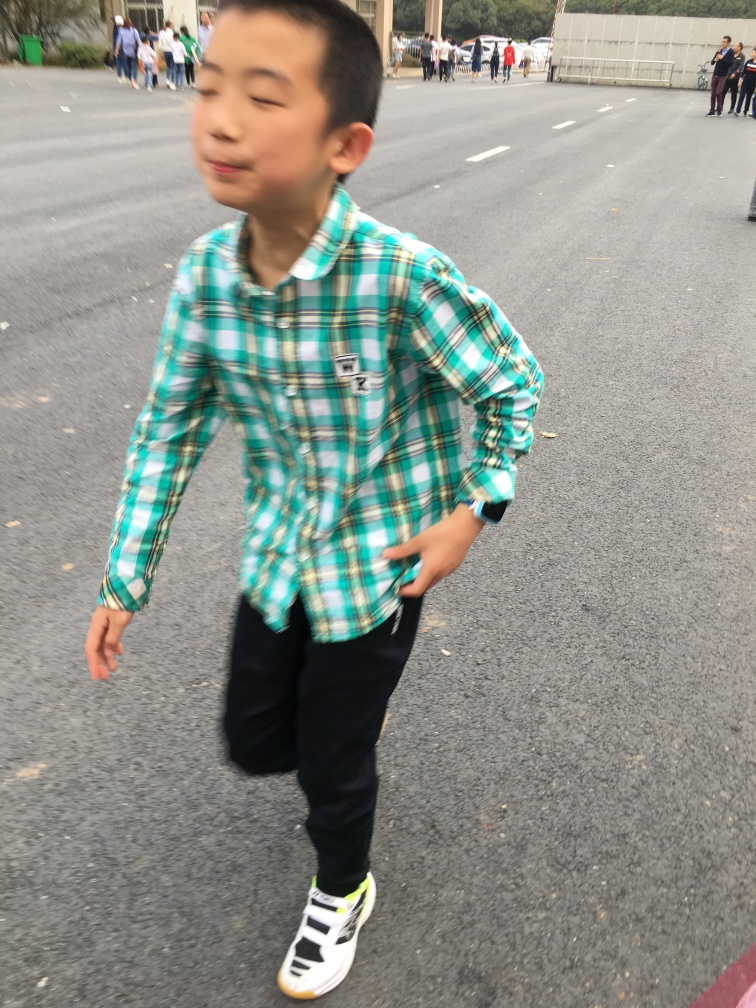Are there any indications about the weather or time of day in the image? The lighting in the image suggests an overcast day, likely with diffuse sunlight. There are no shadows that would indicate strong direct light, and the attire of the individuals, such as the boy's long-sleeve shirt, suggest a mild to cool temperature, common in the earlier or later parts of the day, or during overcast weather conditions. 